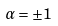Convert formula to latex. <formula><loc_0><loc_0><loc_500><loc_500>\alpha = \pm 1</formula> 